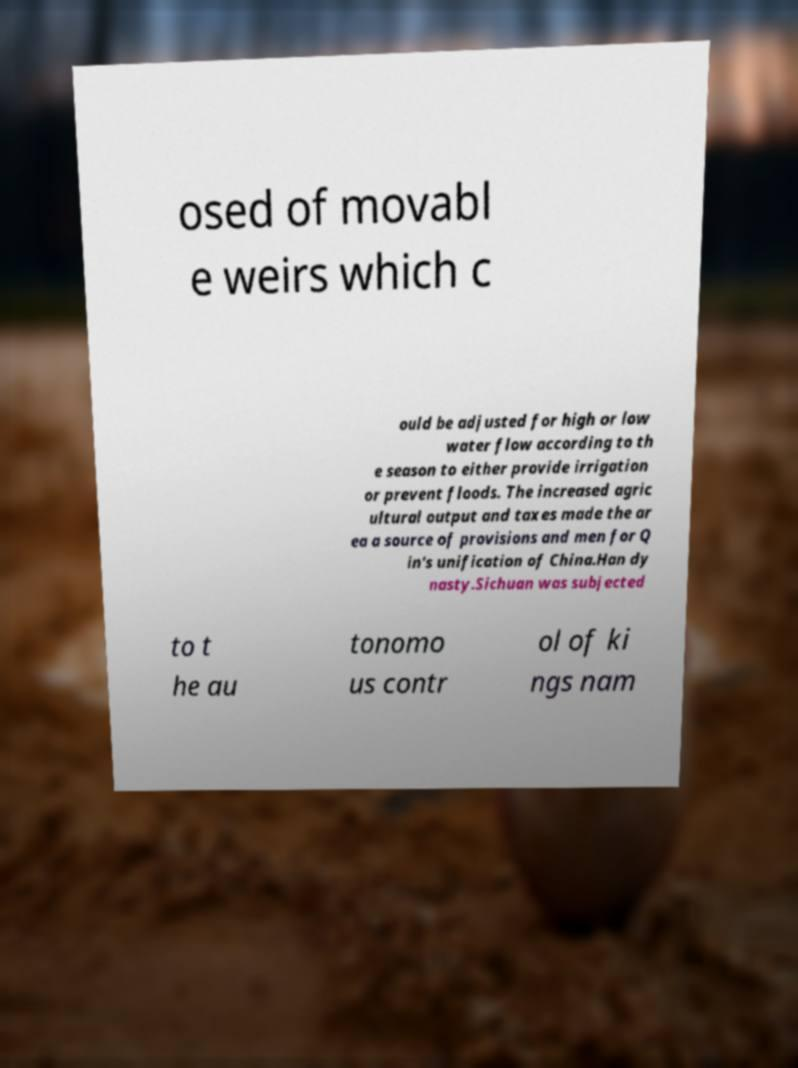What messages or text are displayed in this image? I need them in a readable, typed format. osed of movabl e weirs which c ould be adjusted for high or low water flow according to th e season to either provide irrigation or prevent floods. The increased agric ultural output and taxes made the ar ea a source of provisions and men for Q in's unification of China.Han dy nasty.Sichuan was subjected to t he au tonomo us contr ol of ki ngs nam 